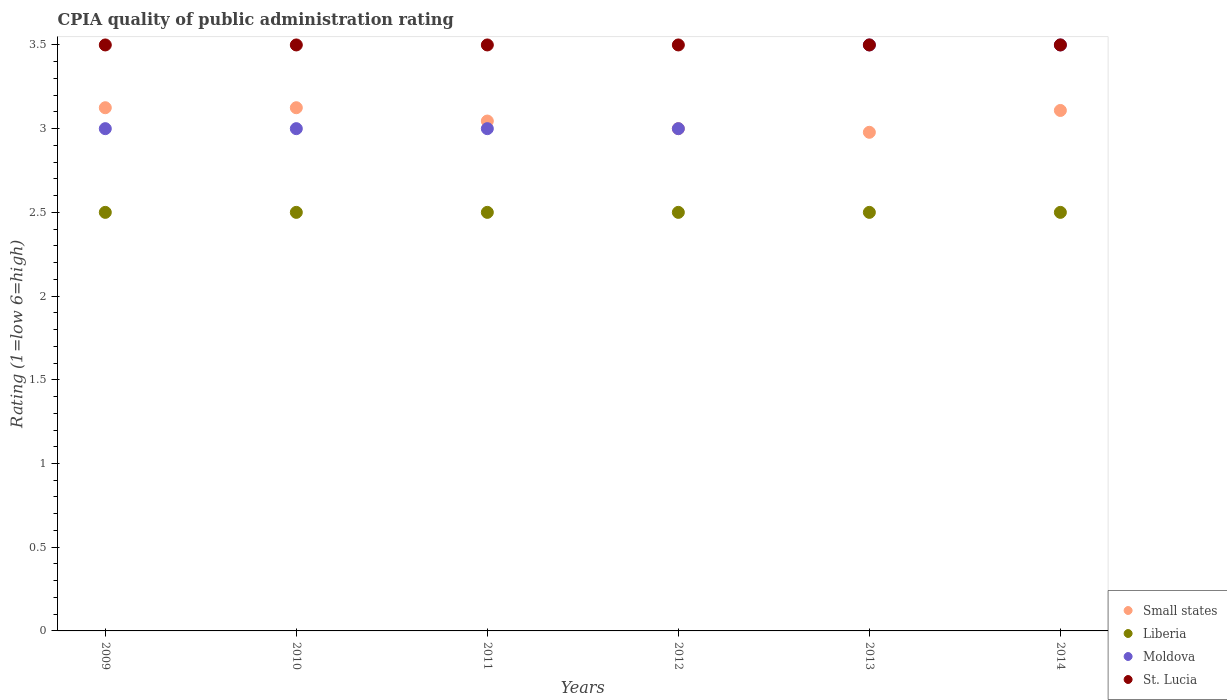How many different coloured dotlines are there?
Make the answer very short. 4. Across all years, what is the maximum CPIA rating in Small states?
Offer a very short reply. 3.12. Across all years, what is the minimum CPIA rating in Moldova?
Provide a short and direct response. 3. In which year was the CPIA rating in St. Lucia maximum?
Your response must be concise. 2009. In which year was the CPIA rating in Moldova minimum?
Offer a terse response. 2009. What is the difference between the CPIA rating in Liberia in 2010 and that in 2012?
Your response must be concise. 0. What is the difference between the CPIA rating in Small states in 2014 and the CPIA rating in Moldova in 2009?
Your answer should be very brief. 0.11. What is the average CPIA rating in Moldova per year?
Your answer should be compact. 3.17. In the year 2012, what is the difference between the CPIA rating in St. Lucia and CPIA rating in Small states?
Offer a terse response. 0.5. In how many years, is the CPIA rating in Liberia greater than 3?
Provide a short and direct response. 0. Is the CPIA rating in Moldova in 2009 less than that in 2014?
Provide a short and direct response. Yes. What is the difference between the highest and the second highest CPIA rating in Small states?
Your response must be concise. 0. In how many years, is the CPIA rating in Moldova greater than the average CPIA rating in Moldova taken over all years?
Your answer should be compact. 2. Is it the case that in every year, the sum of the CPIA rating in Small states and CPIA rating in St. Lucia  is greater than the sum of CPIA rating in Moldova and CPIA rating in Liberia?
Give a very brief answer. Yes. Is it the case that in every year, the sum of the CPIA rating in St. Lucia and CPIA rating in Moldova  is greater than the CPIA rating in Small states?
Offer a very short reply. Yes. Does the CPIA rating in Small states monotonically increase over the years?
Your response must be concise. No. How many dotlines are there?
Your response must be concise. 4. What is the difference between two consecutive major ticks on the Y-axis?
Your answer should be very brief. 0.5. Are the values on the major ticks of Y-axis written in scientific E-notation?
Give a very brief answer. No. Does the graph contain any zero values?
Offer a very short reply. No. Does the graph contain grids?
Provide a short and direct response. No. Where does the legend appear in the graph?
Your response must be concise. Bottom right. How many legend labels are there?
Keep it short and to the point. 4. What is the title of the graph?
Provide a short and direct response. CPIA quality of public administration rating. Does "Rwanda" appear as one of the legend labels in the graph?
Keep it short and to the point. No. What is the label or title of the X-axis?
Provide a short and direct response. Years. What is the label or title of the Y-axis?
Your response must be concise. Rating (1=low 6=high). What is the Rating (1=low 6=high) in Small states in 2009?
Ensure brevity in your answer.  3.12. What is the Rating (1=low 6=high) of St. Lucia in 2009?
Your answer should be very brief. 3.5. What is the Rating (1=low 6=high) in Small states in 2010?
Your response must be concise. 3.12. What is the Rating (1=low 6=high) in Small states in 2011?
Ensure brevity in your answer.  3.05. What is the Rating (1=low 6=high) in Liberia in 2011?
Your answer should be compact. 2.5. What is the Rating (1=low 6=high) in Moldova in 2011?
Keep it short and to the point. 3. What is the Rating (1=low 6=high) in Liberia in 2012?
Provide a succinct answer. 2.5. What is the Rating (1=low 6=high) in St. Lucia in 2012?
Offer a very short reply. 3.5. What is the Rating (1=low 6=high) of Small states in 2013?
Make the answer very short. 2.98. What is the Rating (1=low 6=high) of Liberia in 2013?
Keep it short and to the point. 2.5. What is the Rating (1=low 6=high) of St. Lucia in 2013?
Provide a succinct answer. 3.5. What is the Rating (1=low 6=high) of Small states in 2014?
Make the answer very short. 3.11. What is the Rating (1=low 6=high) of Liberia in 2014?
Make the answer very short. 2.5. Across all years, what is the maximum Rating (1=low 6=high) of Small states?
Give a very brief answer. 3.12. Across all years, what is the maximum Rating (1=low 6=high) in St. Lucia?
Your response must be concise. 3.5. Across all years, what is the minimum Rating (1=low 6=high) of Small states?
Make the answer very short. 2.98. Across all years, what is the minimum Rating (1=low 6=high) of Moldova?
Provide a succinct answer. 3. What is the total Rating (1=low 6=high) in Small states in the graph?
Provide a succinct answer. 18.38. What is the total Rating (1=low 6=high) of Moldova in the graph?
Your response must be concise. 19. What is the total Rating (1=low 6=high) in St. Lucia in the graph?
Offer a very short reply. 21. What is the difference between the Rating (1=low 6=high) in Liberia in 2009 and that in 2010?
Offer a terse response. 0. What is the difference between the Rating (1=low 6=high) of St. Lucia in 2009 and that in 2010?
Your answer should be compact. 0. What is the difference between the Rating (1=low 6=high) in Small states in 2009 and that in 2011?
Offer a very short reply. 0.08. What is the difference between the Rating (1=low 6=high) of St. Lucia in 2009 and that in 2011?
Keep it short and to the point. 0. What is the difference between the Rating (1=low 6=high) in Moldova in 2009 and that in 2012?
Your answer should be compact. 0. What is the difference between the Rating (1=low 6=high) in Small states in 2009 and that in 2013?
Offer a very short reply. 0.15. What is the difference between the Rating (1=low 6=high) in Small states in 2009 and that in 2014?
Your answer should be compact. 0.02. What is the difference between the Rating (1=low 6=high) in Liberia in 2009 and that in 2014?
Offer a terse response. 0. What is the difference between the Rating (1=low 6=high) of St. Lucia in 2009 and that in 2014?
Make the answer very short. 0. What is the difference between the Rating (1=low 6=high) of Small states in 2010 and that in 2011?
Your response must be concise. 0.08. What is the difference between the Rating (1=low 6=high) in Small states in 2010 and that in 2012?
Provide a succinct answer. 0.12. What is the difference between the Rating (1=low 6=high) of Moldova in 2010 and that in 2012?
Your response must be concise. 0. What is the difference between the Rating (1=low 6=high) of St. Lucia in 2010 and that in 2012?
Give a very brief answer. 0. What is the difference between the Rating (1=low 6=high) in Small states in 2010 and that in 2013?
Keep it short and to the point. 0.15. What is the difference between the Rating (1=low 6=high) in Liberia in 2010 and that in 2013?
Keep it short and to the point. 0. What is the difference between the Rating (1=low 6=high) in Moldova in 2010 and that in 2013?
Provide a succinct answer. -0.5. What is the difference between the Rating (1=low 6=high) in St. Lucia in 2010 and that in 2013?
Make the answer very short. 0. What is the difference between the Rating (1=low 6=high) of Small states in 2010 and that in 2014?
Ensure brevity in your answer.  0.02. What is the difference between the Rating (1=low 6=high) of Liberia in 2010 and that in 2014?
Your answer should be very brief. 0. What is the difference between the Rating (1=low 6=high) in St. Lucia in 2010 and that in 2014?
Offer a terse response. 0. What is the difference between the Rating (1=low 6=high) of Small states in 2011 and that in 2012?
Your response must be concise. 0.05. What is the difference between the Rating (1=low 6=high) in Small states in 2011 and that in 2013?
Your response must be concise. 0.07. What is the difference between the Rating (1=low 6=high) of Small states in 2011 and that in 2014?
Offer a terse response. -0.06. What is the difference between the Rating (1=low 6=high) in Moldova in 2011 and that in 2014?
Your answer should be very brief. -0.5. What is the difference between the Rating (1=low 6=high) in St. Lucia in 2011 and that in 2014?
Provide a short and direct response. 0. What is the difference between the Rating (1=low 6=high) of Small states in 2012 and that in 2013?
Keep it short and to the point. 0.02. What is the difference between the Rating (1=low 6=high) in Liberia in 2012 and that in 2013?
Offer a very short reply. 0. What is the difference between the Rating (1=low 6=high) of Moldova in 2012 and that in 2013?
Your answer should be very brief. -0.5. What is the difference between the Rating (1=low 6=high) in St. Lucia in 2012 and that in 2013?
Keep it short and to the point. 0. What is the difference between the Rating (1=low 6=high) of Small states in 2012 and that in 2014?
Provide a succinct answer. -0.11. What is the difference between the Rating (1=low 6=high) in Moldova in 2012 and that in 2014?
Provide a short and direct response. -0.5. What is the difference between the Rating (1=low 6=high) of Small states in 2013 and that in 2014?
Provide a succinct answer. -0.13. What is the difference between the Rating (1=low 6=high) in Moldova in 2013 and that in 2014?
Offer a terse response. 0. What is the difference between the Rating (1=low 6=high) in Small states in 2009 and the Rating (1=low 6=high) in St. Lucia in 2010?
Keep it short and to the point. -0.38. What is the difference between the Rating (1=low 6=high) in Small states in 2009 and the Rating (1=low 6=high) in Liberia in 2011?
Give a very brief answer. 0.62. What is the difference between the Rating (1=low 6=high) of Small states in 2009 and the Rating (1=low 6=high) of Moldova in 2011?
Ensure brevity in your answer.  0.12. What is the difference between the Rating (1=low 6=high) of Small states in 2009 and the Rating (1=low 6=high) of St. Lucia in 2011?
Offer a very short reply. -0.38. What is the difference between the Rating (1=low 6=high) of Liberia in 2009 and the Rating (1=low 6=high) of Moldova in 2011?
Ensure brevity in your answer.  -0.5. What is the difference between the Rating (1=low 6=high) of Liberia in 2009 and the Rating (1=low 6=high) of St. Lucia in 2011?
Offer a terse response. -1. What is the difference between the Rating (1=low 6=high) in Small states in 2009 and the Rating (1=low 6=high) in Liberia in 2012?
Your answer should be compact. 0.62. What is the difference between the Rating (1=low 6=high) in Small states in 2009 and the Rating (1=low 6=high) in Moldova in 2012?
Your answer should be compact. 0.12. What is the difference between the Rating (1=low 6=high) in Small states in 2009 and the Rating (1=low 6=high) in St. Lucia in 2012?
Ensure brevity in your answer.  -0.38. What is the difference between the Rating (1=low 6=high) in Liberia in 2009 and the Rating (1=low 6=high) in Moldova in 2012?
Your answer should be very brief. -0.5. What is the difference between the Rating (1=low 6=high) in Moldova in 2009 and the Rating (1=low 6=high) in St. Lucia in 2012?
Provide a succinct answer. -0.5. What is the difference between the Rating (1=low 6=high) in Small states in 2009 and the Rating (1=low 6=high) in Liberia in 2013?
Your response must be concise. 0.62. What is the difference between the Rating (1=low 6=high) of Small states in 2009 and the Rating (1=low 6=high) of Moldova in 2013?
Keep it short and to the point. -0.38. What is the difference between the Rating (1=low 6=high) in Small states in 2009 and the Rating (1=low 6=high) in St. Lucia in 2013?
Make the answer very short. -0.38. What is the difference between the Rating (1=low 6=high) of Small states in 2009 and the Rating (1=low 6=high) of Moldova in 2014?
Ensure brevity in your answer.  -0.38. What is the difference between the Rating (1=low 6=high) of Small states in 2009 and the Rating (1=low 6=high) of St. Lucia in 2014?
Ensure brevity in your answer.  -0.38. What is the difference between the Rating (1=low 6=high) in Moldova in 2009 and the Rating (1=low 6=high) in St. Lucia in 2014?
Make the answer very short. -0.5. What is the difference between the Rating (1=low 6=high) of Small states in 2010 and the Rating (1=low 6=high) of Liberia in 2011?
Give a very brief answer. 0.62. What is the difference between the Rating (1=low 6=high) in Small states in 2010 and the Rating (1=low 6=high) in St. Lucia in 2011?
Provide a short and direct response. -0.38. What is the difference between the Rating (1=low 6=high) in Liberia in 2010 and the Rating (1=low 6=high) in St. Lucia in 2011?
Provide a succinct answer. -1. What is the difference between the Rating (1=low 6=high) of Moldova in 2010 and the Rating (1=low 6=high) of St. Lucia in 2011?
Your response must be concise. -0.5. What is the difference between the Rating (1=low 6=high) in Small states in 2010 and the Rating (1=low 6=high) in Liberia in 2012?
Keep it short and to the point. 0.62. What is the difference between the Rating (1=low 6=high) in Small states in 2010 and the Rating (1=low 6=high) in Moldova in 2012?
Ensure brevity in your answer.  0.12. What is the difference between the Rating (1=low 6=high) in Small states in 2010 and the Rating (1=low 6=high) in St. Lucia in 2012?
Offer a terse response. -0.38. What is the difference between the Rating (1=low 6=high) in Liberia in 2010 and the Rating (1=low 6=high) in St. Lucia in 2012?
Provide a short and direct response. -1. What is the difference between the Rating (1=low 6=high) in Small states in 2010 and the Rating (1=low 6=high) in Moldova in 2013?
Keep it short and to the point. -0.38. What is the difference between the Rating (1=low 6=high) in Small states in 2010 and the Rating (1=low 6=high) in St. Lucia in 2013?
Your response must be concise. -0.38. What is the difference between the Rating (1=low 6=high) in Liberia in 2010 and the Rating (1=low 6=high) in Moldova in 2013?
Offer a terse response. -1. What is the difference between the Rating (1=low 6=high) in Liberia in 2010 and the Rating (1=low 6=high) in St. Lucia in 2013?
Your answer should be very brief. -1. What is the difference between the Rating (1=low 6=high) in Small states in 2010 and the Rating (1=low 6=high) in Liberia in 2014?
Your answer should be compact. 0.62. What is the difference between the Rating (1=low 6=high) in Small states in 2010 and the Rating (1=low 6=high) in Moldova in 2014?
Offer a very short reply. -0.38. What is the difference between the Rating (1=low 6=high) in Small states in 2010 and the Rating (1=low 6=high) in St. Lucia in 2014?
Provide a succinct answer. -0.38. What is the difference between the Rating (1=low 6=high) in Liberia in 2010 and the Rating (1=low 6=high) in Moldova in 2014?
Give a very brief answer. -1. What is the difference between the Rating (1=low 6=high) of Liberia in 2010 and the Rating (1=low 6=high) of St. Lucia in 2014?
Give a very brief answer. -1. What is the difference between the Rating (1=low 6=high) in Small states in 2011 and the Rating (1=low 6=high) in Liberia in 2012?
Make the answer very short. 0.55. What is the difference between the Rating (1=low 6=high) in Small states in 2011 and the Rating (1=low 6=high) in Moldova in 2012?
Provide a short and direct response. 0.05. What is the difference between the Rating (1=low 6=high) in Small states in 2011 and the Rating (1=low 6=high) in St. Lucia in 2012?
Your answer should be compact. -0.45. What is the difference between the Rating (1=low 6=high) in Moldova in 2011 and the Rating (1=low 6=high) in St. Lucia in 2012?
Your answer should be very brief. -0.5. What is the difference between the Rating (1=low 6=high) in Small states in 2011 and the Rating (1=low 6=high) in Liberia in 2013?
Your answer should be very brief. 0.55. What is the difference between the Rating (1=low 6=high) in Small states in 2011 and the Rating (1=low 6=high) in Moldova in 2013?
Keep it short and to the point. -0.45. What is the difference between the Rating (1=low 6=high) in Small states in 2011 and the Rating (1=low 6=high) in St. Lucia in 2013?
Your response must be concise. -0.45. What is the difference between the Rating (1=low 6=high) of Liberia in 2011 and the Rating (1=low 6=high) of Moldova in 2013?
Your response must be concise. -1. What is the difference between the Rating (1=low 6=high) of Liberia in 2011 and the Rating (1=low 6=high) of St. Lucia in 2013?
Ensure brevity in your answer.  -1. What is the difference between the Rating (1=low 6=high) of Small states in 2011 and the Rating (1=low 6=high) of Liberia in 2014?
Offer a very short reply. 0.55. What is the difference between the Rating (1=low 6=high) of Small states in 2011 and the Rating (1=low 6=high) of Moldova in 2014?
Keep it short and to the point. -0.45. What is the difference between the Rating (1=low 6=high) of Small states in 2011 and the Rating (1=low 6=high) of St. Lucia in 2014?
Give a very brief answer. -0.45. What is the difference between the Rating (1=low 6=high) in Liberia in 2011 and the Rating (1=low 6=high) in Moldova in 2014?
Give a very brief answer. -1. What is the difference between the Rating (1=low 6=high) of Small states in 2012 and the Rating (1=low 6=high) of Liberia in 2013?
Make the answer very short. 0.5. What is the difference between the Rating (1=low 6=high) of Small states in 2012 and the Rating (1=low 6=high) of Moldova in 2013?
Make the answer very short. -0.5. What is the difference between the Rating (1=low 6=high) in Small states in 2012 and the Rating (1=low 6=high) in St. Lucia in 2013?
Your response must be concise. -0.5. What is the difference between the Rating (1=low 6=high) in Liberia in 2012 and the Rating (1=low 6=high) in Moldova in 2013?
Offer a very short reply. -1. What is the difference between the Rating (1=low 6=high) in Moldova in 2012 and the Rating (1=low 6=high) in St. Lucia in 2013?
Ensure brevity in your answer.  -0.5. What is the difference between the Rating (1=low 6=high) of Small states in 2012 and the Rating (1=low 6=high) of Moldova in 2014?
Your answer should be compact. -0.5. What is the difference between the Rating (1=low 6=high) in Small states in 2013 and the Rating (1=low 6=high) in Liberia in 2014?
Give a very brief answer. 0.48. What is the difference between the Rating (1=low 6=high) in Small states in 2013 and the Rating (1=low 6=high) in Moldova in 2014?
Give a very brief answer. -0.52. What is the difference between the Rating (1=low 6=high) in Small states in 2013 and the Rating (1=low 6=high) in St. Lucia in 2014?
Make the answer very short. -0.52. What is the difference between the Rating (1=low 6=high) of Liberia in 2013 and the Rating (1=low 6=high) of St. Lucia in 2014?
Ensure brevity in your answer.  -1. What is the difference between the Rating (1=low 6=high) in Moldova in 2013 and the Rating (1=low 6=high) in St. Lucia in 2014?
Provide a succinct answer. 0. What is the average Rating (1=low 6=high) of Small states per year?
Your answer should be compact. 3.06. What is the average Rating (1=low 6=high) in Liberia per year?
Provide a succinct answer. 2.5. What is the average Rating (1=low 6=high) in Moldova per year?
Your answer should be compact. 3.17. What is the average Rating (1=low 6=high) of St. Lucia per year?
Offer a terse response. 3.5. In the year 2009, what is the difference between the Rating (1=low 6=high) of Small states and Rating (1=low 6=high) of Liberia?
Your response must be concise. 0.62. In the year 2009, what is the difference between the Rating (1=low 6=high) of Small states and Rating (1=low 6=high) of Moldova?
Ensure brevity in your answer.  0.12. In the year 2009, what is the difference between the Rating (1=low 6=high) in Small states and Rating (1=low 6=high) in St. Lucia?
Make the answer very short. -0.38. In the year 2009, what is the difference between the Rating (1=low 6=high) in Liberia and Rating (1=low 6=high) in St. Lucia?
Keep it short and to the point. -1. In the year 2010, what is the difference between the Rating (1=low 6=high) of Small states and Rating (1=low 6=high) of Moldova?
Make the answer very short. 0.12. In the year 2010, what is the difference between the Rating (1=low 6=high) of Small states and Rating (1=low 6=high) of St. Lucia?
Keep it short and to the point. -0.38. In the year 2010, what is the difference between the Rating (1=low 6=high) of Liberia and Rating (1=low 6=high) of Moldova?
Your response must be concise. -0.5. In the year 2010, what is the difference between the Rating (1=low 6=high) in Liberia and Rating (1=low 6=high) in St. Lucia?
Your response must be concise. -1. In the year 2011, what is the difference between the Rating (1=low 6=high) of Small states and Rating (1=low 6=high) of Liberia?
Your response must be concise. 0.55. In the year 2011, what is the difference between the Rating (1=low 6=high) of Small states and Rating (1=low 6=high) of Moldova?
Your response must be concise. 0.05. In the year 2011, what is the difference between the Rating (1=low 6=high) in Small states and Rating (1=low 6=high) in St. Lucia?
Offer a very short reply. -0.45. In the year 2011, what is the difference between the Rating (1=low 6=high) in Moldova and Rating (1=low 6=high) in St. Lucia?
Keep it short and to the point. -0.5. In the year 2012, what is the difference between the Rating (1=low 6=high) of Small states and Rating (1=low 6=high) of Liberia?
Ensure brevity in your answer.  0.5. In the year 2012, what is the difference between the Rating (1=low 6=high) in Small states and Rating (1=low 6=high) in St. Lucia?
Make the answer very short. -0.5. In the year 2012, what is the difference between the Rating (1=low 6=high) in Liberia and Rating (1=low 6=high) in Moldova?
Ensure brevity in your answer.  -0.5. In the year 2012, what is the difference between the Rating (1=low 6=high) of Liberia and Rating (1=low 6=high) of St. Lucia?
Provide a short and direct response. -1. In the year 2013, what is the difference between the Rating (1=low 6=high) in Small states and Rating (1=low 6=high) in Liberia?
Offer a terse response. 0.48. In the year 2013, what is the difference between the Rating (1=low 6=high) in Small states and Rating (1=low 6=high) in Moldova?
Provide a succinct answer. -0.52. In the year 2013, what is the difference between the Rating (1=low 6=high) of Small states and Rating (1=low 6=high) of St. Lucia?
Provide a short and direct response. -0.52. In the year 2014, what is the difference between the Rating (1=low 6=high) in Small states and Rating (1=low 6=high) in Liberia?
Your answer should be very brief. 0.61. In the year 2014, what is the difference between the Rating (1=low 6=high) of Small states and Rating (1=low 6=high) of Moldova?
Make the answer very short. -0.39. In the year 2014, what is the difference between the Rating (1=low 6=high) in Small states and Rating (1=low 6=high) in St. Lucia?
Offer a terse response. -0.39. In the year 2014, what is the difference between the Rating (1=low 6=high) of Liberia and Rating (1=low 6=high) of St. Lucia?
Your answer should be very brief. -1. In the year 2014, what is the difference between the Rating (1=low 6=high) in Moldova and Rating (1=low 6=high) in St. Lucia?
Make the answer very short. 0. What is the ratio of the Rating (1=low 6=high) of Moldova in 2009 to that in 2010?
Give a very brief answer. 1. What is the ratio of the Rating (1=low 6=high) of Small states in 2009 to that in 2011?
Make the answer very short. 1.03. What is the ratio of the Rating (1=low 6=high) in Moldova in 2009 to that in 2011?
Ensure brevity in your answer.  1. What is the ratio of the Rating (1=low 6=high) of Small states in 2009 to that in 2012?
Provide a short and direct response. 1.04. What is the ratio of the Rating (1=low 6=high) in Liberia in 2009 to that in 2012?
Ensure brevity in your answer.  1. What is the ratio of the Rating (1=low 6=high) in Moldova in 2009 to that in 2012?
Offer a terse response. 1. What is the ratio of the Rating (1=low 6=high) of Small states in 2009 to that in 2013?
Provide a short and direct response. 1.05. What is the ratio of the Rating (1=low 6=high) of Liberia in 2009 to that in 2013?
Make the answer very short. 1. What is the ratio of the Rating (1=low 6=high) of Moldova in 2009 to that in 2013?
Provide a succinct answer. 0.86. What is the ratio of the Rating (1=low 6=high) in St. Lucia in 2009 to that in 2013?
Offer a very short reply. 1. What is the ratio of the Rating (1=low 6=high) of Small states in 2009 to that in 2014?
Make the answer very short. 1.01. What is the ratio of the Rating (1=low 6=high) in Moldova in 2009 to that in 2014?
Ensure brevity in your answer.  0.86. What is the ratio of the Rating (1=low 6=high) of St. Lucia in 2009 to that in 2014?
Offer a terse response. 1. What is the ratio of the Rating (1=low 6=high) in Small states in 2010 to that in 2011?
Your answer should be compact. 1.03. What is the ratio of the Rating (1=low 6=high) of Liberia in 2010 to that in 2011?
Your answer should be compact. 1. What is the ratio of the Rating (1=low 6=high) of Moldova in 2010 to that in 2011?
Ensure brevity in your answer.  1. What is the ratio of the Rating (1=low 6=high) in St. Lucia in 2010 to that in 2011?
Your answer should be very brief. 1. What is the ratio of the Rating (1=low 6=high) in Small states in 2010 to that in 2012?
Make the answer very short. 1.04. What is the ratio of the Rating (1=low 6=high) in Liberia in 2010 to that in 2012?
Offer a terse response. 1. What is the ratio of the Rating (1=low 6=high) of Small states in 2010 to that in 2013?
Ensure brevity in your answer.  1.05. What is the ratio of the Rating (1=low 6=high) of Moldova in 2010 to that in 2013?
Offer a very short reply. 0.86. What is the ratio of the Rating (1=low 6=high) of St. Lucia in 2010 to that in 2013?
Ensure brevity in your answer.  1. What is the ratio of the Rating (1=low 6=high) in Small states in 2010 to that in 2014?
Ensure brevity in your answer.  1.01. What is the ratio of the Rating (1=low 6=high) in Liberia in 2010 to that in 2014?
Your response must be concise. 1. What is the ratio of the Rating (1=low 6=high) in Moldova in 2010 to that in 2014?
Make the answer very short. 0.86. What is the ratio of the Rating (1=low 6=high) of Small states in 2011 to that in 2012?
Provide a succinct answer. 1.02. What is the ratio of the Rating (1=low 6=high) of St. Lucia in 2011 to that in 2012?
Give a very brief answer. 1. What is the ratio of the Rating (1=low 6=high) of Small states in 2011 to that in 2013?
Your answer should be compact. 1.02. What is the ratio of the Rating (1=low 6=high) of Liberia in 2011 to that in 2013?
Ensure brevity in your answer.  1. What is the ratio of the Rating (1=low 6=high) in Moldova in 2011 to that in 2013?
Ensure brevity in your answer.  0.86. What is the ratio of the Rating (1=low 6=high) of Small states in 2011 to that in 2014?
Make the answer very short. 0.98. What is the ratio of the Rating (1=low 6=high) in Small states in 2012 to that in 2013?
Keep it short and to the point. 1.01. What is the ratio of the Rating (1=low 6=high) in Liberia in 2012 to that in 2013?
Provide a short and direct response. 1. What is the ratio of the Rating (1=low 6=high) of St. Lucia in 2012 to that in 2013?
Offer a very short reply. 1. What is the ratio of the Rating (1=low 6=high) of St. Lucia in 2012 to that in 2014?
Your answer should be very brief. 1. What is the ratio of the Rating (1=low 6=high) of Small states in 2013 to that in 2014?
Ensure brevity in your answer.  0.96. What is the ratio of the Rating (1=low 6=high) of Liberia in 2013 to that in 2014?
Give a very brief answer. 1. What is the difference between the highest and the second highest Rating (1=low 6=high) of Small states?
Keep it short and to the point. 0. What is the difference between the highest and the second highest Rating (1=low 6=high) of Liberia?
Ensure brevity in your answer.  0. What is the difference between the highest and the second highest Rating (1=low 6=high) in Moldova?
Keep it short and to the point. 0. What is the difference between the highest and the lowest Rating (1=low 6=high) in Small states?
Ensure brevity in your answer.  0.15. What is the difference between the highest and the lowest Rating (1=low 6=high) of Liberia?
Your answer should be very brief. 0. What is the difference between the highest and the lowest Rating (1=low 6=high) in Moldova?
Make the answer very short. 0.5. What is the difference between the highest and the lowest Rating (1=low 6=high) of St. Lucia?
Ensure brevity in your answer.  0. 